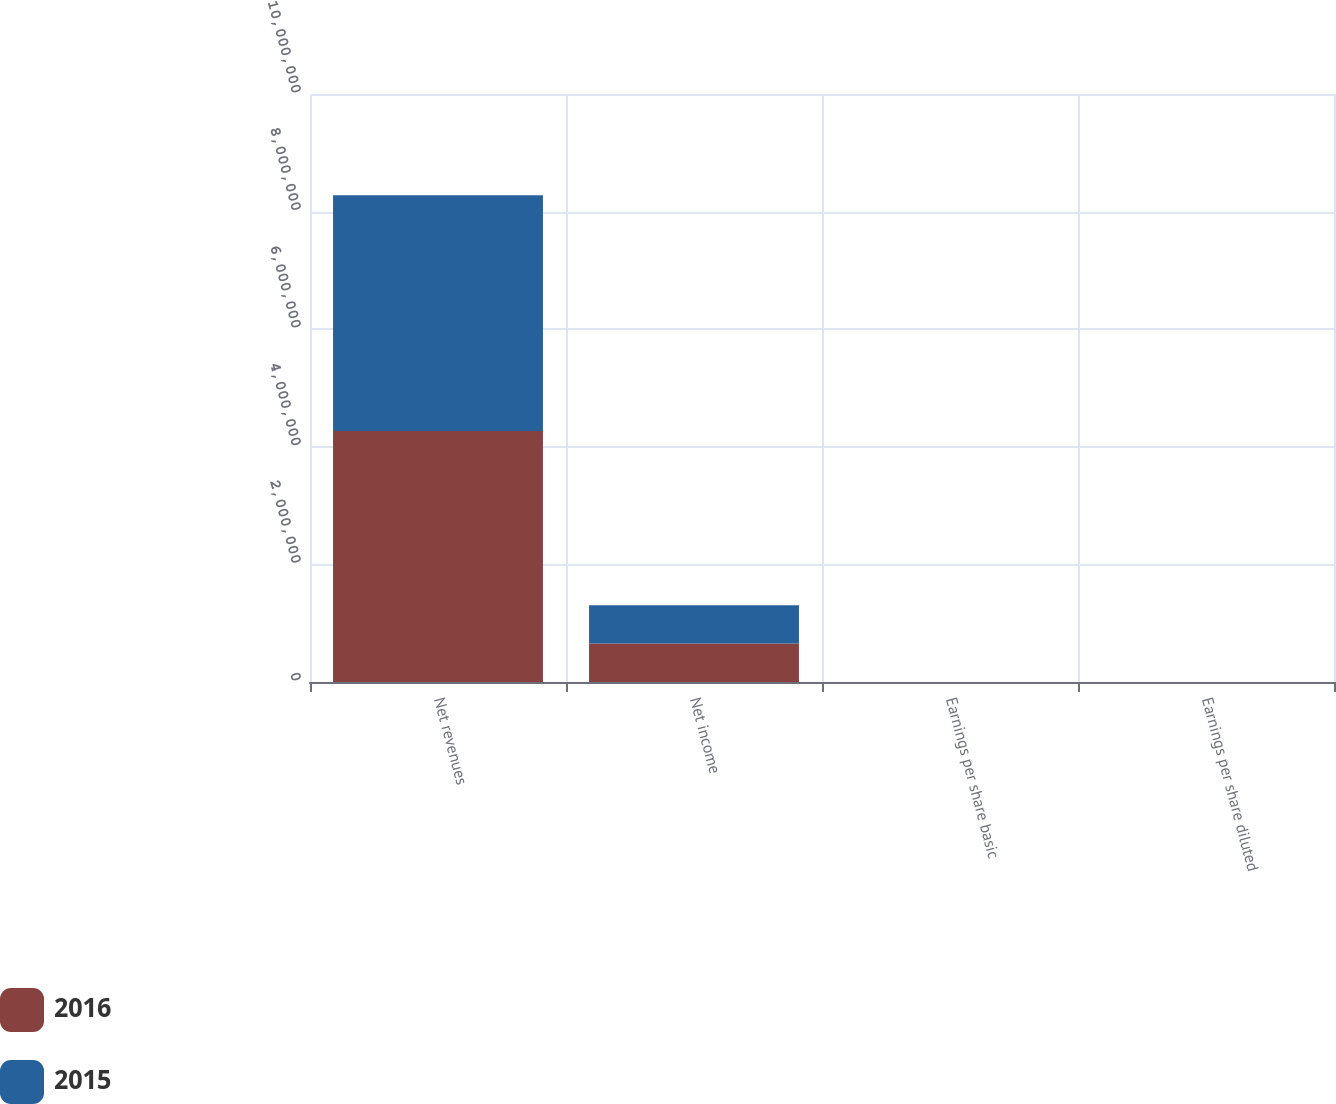Convert chart. <chart><loc_0><loc_0><loc_500><loc_500><stacked_bar_chart><ecel><fcel>Net revenues<fcel>Net income<fcel>Earnings per share basic<fcel>Earnings per share diluted<nl><fcel>2016<fcel>4.26805e+06<fcel>656404<fcel>6.48<fcel>6.41<nl><fcel>2015<fcel>4.01203e+06<fcel>647089<fcel>6.43<fcel>6.37<nl></chart> 